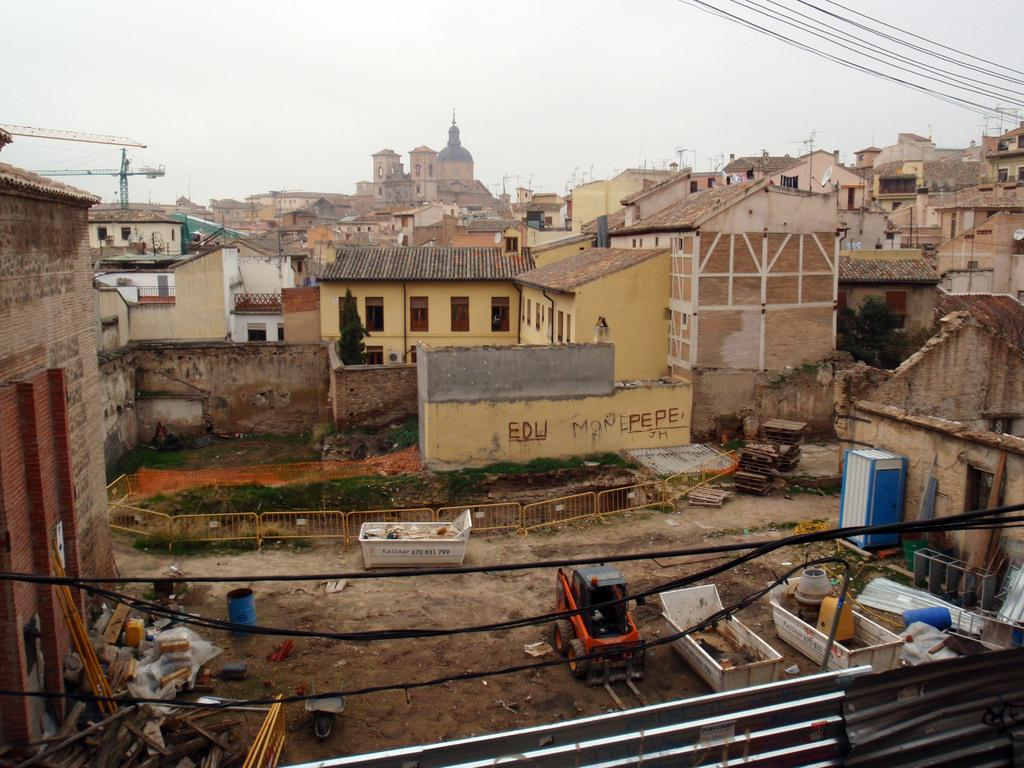What type of structures can be seen in the image? There are buildings in the image. What else is present in the image besides buildings? There are vehicles, poles, wires, other objects on the ground, and the sky is visible in the background. Can you describe the vehicles in the image? The provided facts do not specify the type of vehicles, so we cannot describe them. What is the condition of the sky in the image? The sky is visible in the background of the image, but the facts do not specify its condition. How does the sand interact with the anger in the image? There is no sand or anger present in the image. What type of pump is visible in the image? There is no pump present in the image. 